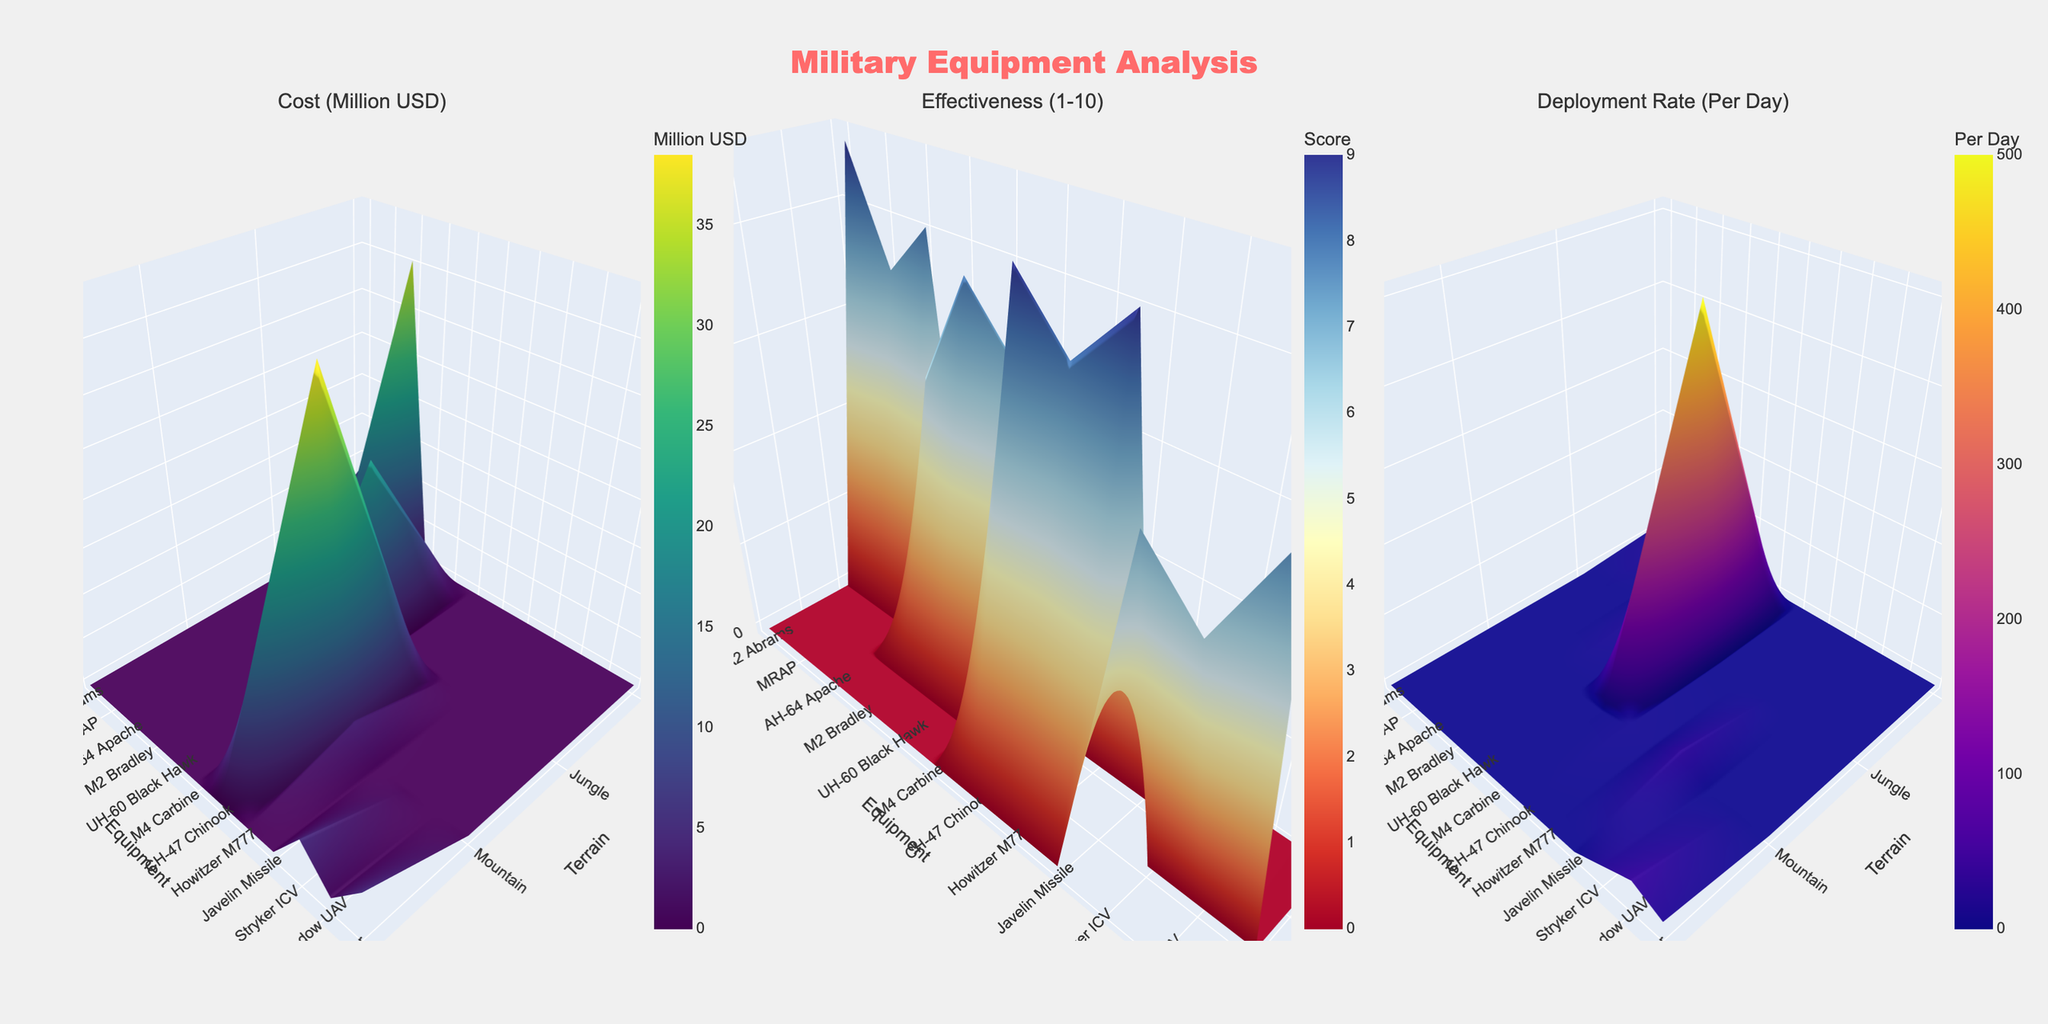What are the terrains labeled on the x-axes? The x-axes in each subplot are labeled with the different terrains represented in the dataset. By looking at the tick labels, we can see the terrains: Desert, Jungle, Mountain, and Urban.
Answer: Desert, Jungle, Mountain, Urban Which equipment has the highest cost in the Mountain terrain? In the first subplot that shows the costs, look at the values along the Mountain terrain. The CH-47 Chinook has the highest cost, identified by the tallest point in this section.
Answer: CH-47 Chinook What is the average deployment rate for equipment in the Urban terrain? In the deployment rate subplot, identify all deployment rates in the Urban terrain. Sum these values (20 for Stryker ICV, 40 for RQ-7 Shadow UAV, 18 for M1126 Stryker) and divide by the number of equipment (3). Calculation: (20 + 40 + 18) / 3 = 78 / 3 = 26.
Answer: 26 Which terrain has the lowest average effectiveness score? Compare the average of effectiveness scores for all equipment within each terrain in the effectiveness subplot. Calculate: 
Desert - (9 + 7 + 8) / 3 = 8, 
Jungle - (6 + 8 + 7) / 3 = 7, 
Mountain - (9 + 8 + 9) / 3 = 8.67, 
Urban - (7 + 6 + 8) / 3 = 7. 
Jungle and Urban have an equal average effectiveness score of 7, but Jungle appears first.
Answer: Jungle How does the deployment rate of the M2 Bradley in Jungle compare to the AH-64 Apache in Desert? Look at the deployment rate subplot. The M2 Bradley in Jungle has a deployment rate of 15 per day, while the AH-64 Apache in Desert has a rate of 8 per day. 15 is greater than 8.
Answer: M2 Bradley has a higher deployment rate Which equipment is the least effective in Urban terrain? Check the effectiveness subplot for the Urban terrain and identify the lowest effectiveness score. The RQ-7 Shadow UAV has the lowest score of 6.
Answer: RQ-7 Shadow UAV What is the difference in cost between the most and least expensive equipment in Desert terrain? In the cost subplot, find the values in the Desert terrain. The most expensive is AH-64 Apache ($35.5M) and the least is M4 Carbine ($0.0007M). Calculate the difference: 35.5 - 0.0007 = 35.4993.
Answer: 35.4993 million USD Which equipment has the highest deployment rate per day across all terrains? In the deployment rate subplot, identify the highest deployment rate. M4 Carbine in Jungle has the highest rate of 500 per day.
Answer: M4 Carbine Compare the effectiveness of the M1126 Stryker in Urban terrain to that of the Howitzer M777 in Mountain terrain. On the effectiveness subplot, note the effectiveness score for M1126 Stryker (8) in the Urban terrain and Howitzer M777 (8) in the Mountain terrain. They both have equal scores.
Answer: They have the same effectiveness How does the cost of the MRAP in Desert compare to the Javelin Missile in Mountain? Check the cost subplot for the Desert terrain to find the MRAP cost (1.1 million USD) and for the Mountain terrain to find the Javelin Missile cost (0.24 million USD). Compare these values: 1.1 is greater than 0.24.
Answer: MRAP has a higher cost 